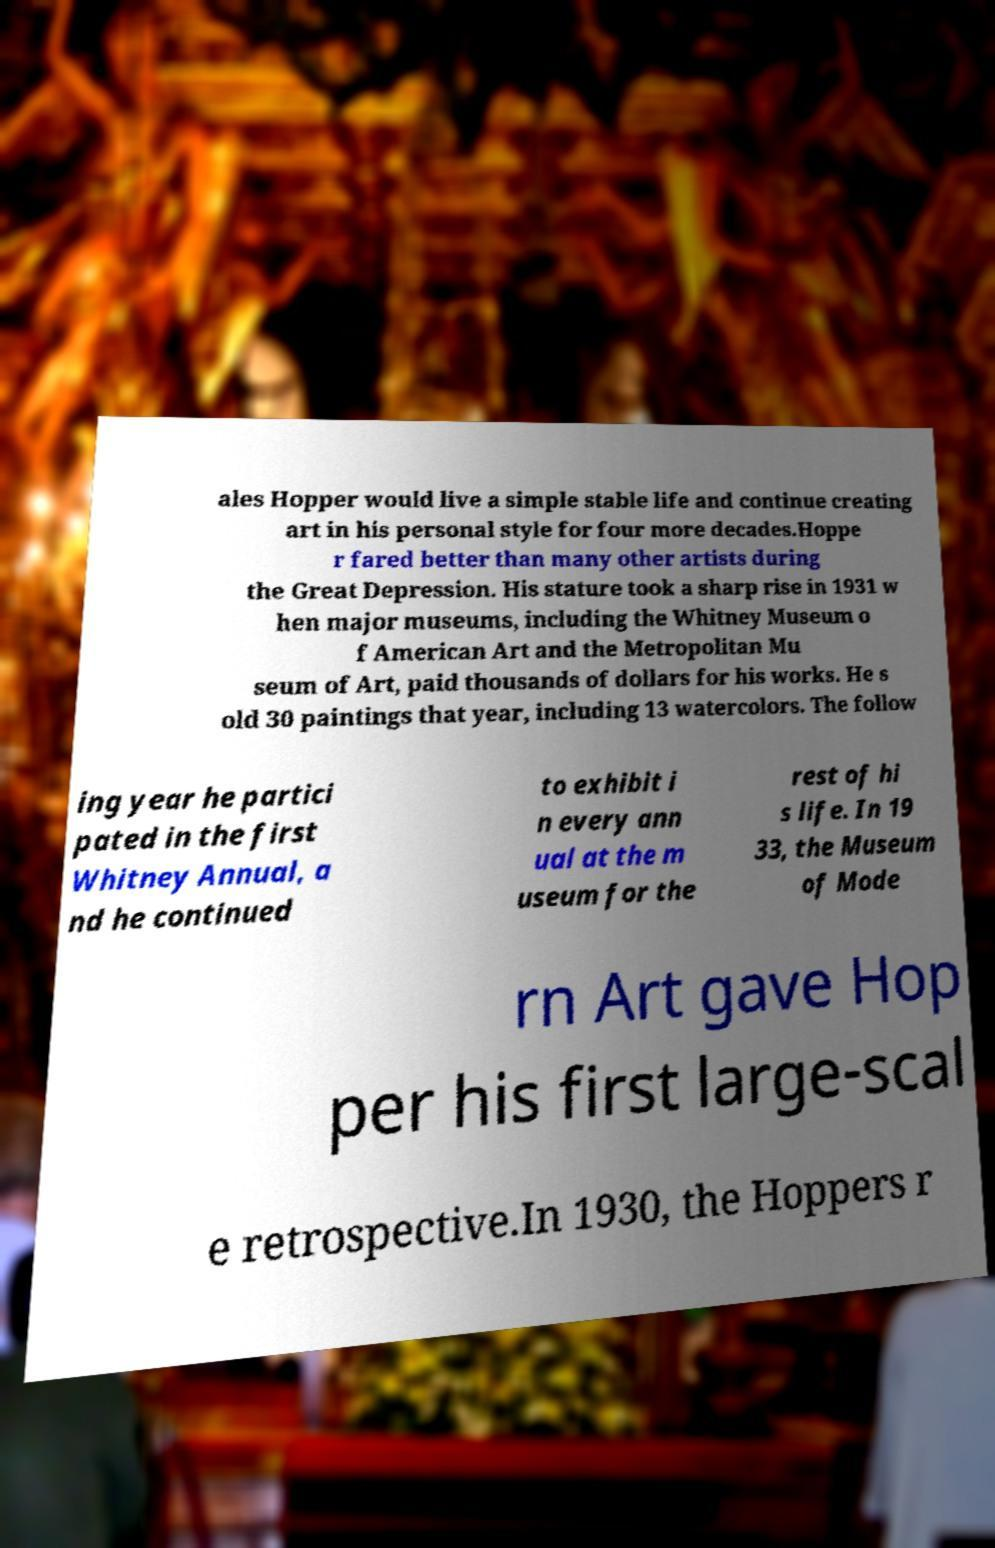Could you assist in decoding the text presented in this image and type it out clearly? ales Hopper would live a simple stable life and continue creating art in his personal style for four more decades.Hoppe r fared better than many other artists during the Great Depression. His stature took a sharp rise in 1931 w hen major museums, including the Whitney Museum o f American Art and the Metropolitan Mu seum of Art, paid thousands of dollars for his works. He s old 30 paintings that year, including 13 watercolors. The follow ing year he partici pated in the first Whitney Annual, a nd he continued to exhibit i n every ann ual at the m useum for the rest of hi s life. In 19 33, the Museum of Mode rn Art gave Hop per his first large-scal e retrospective.In 1930, the Hoppers r 